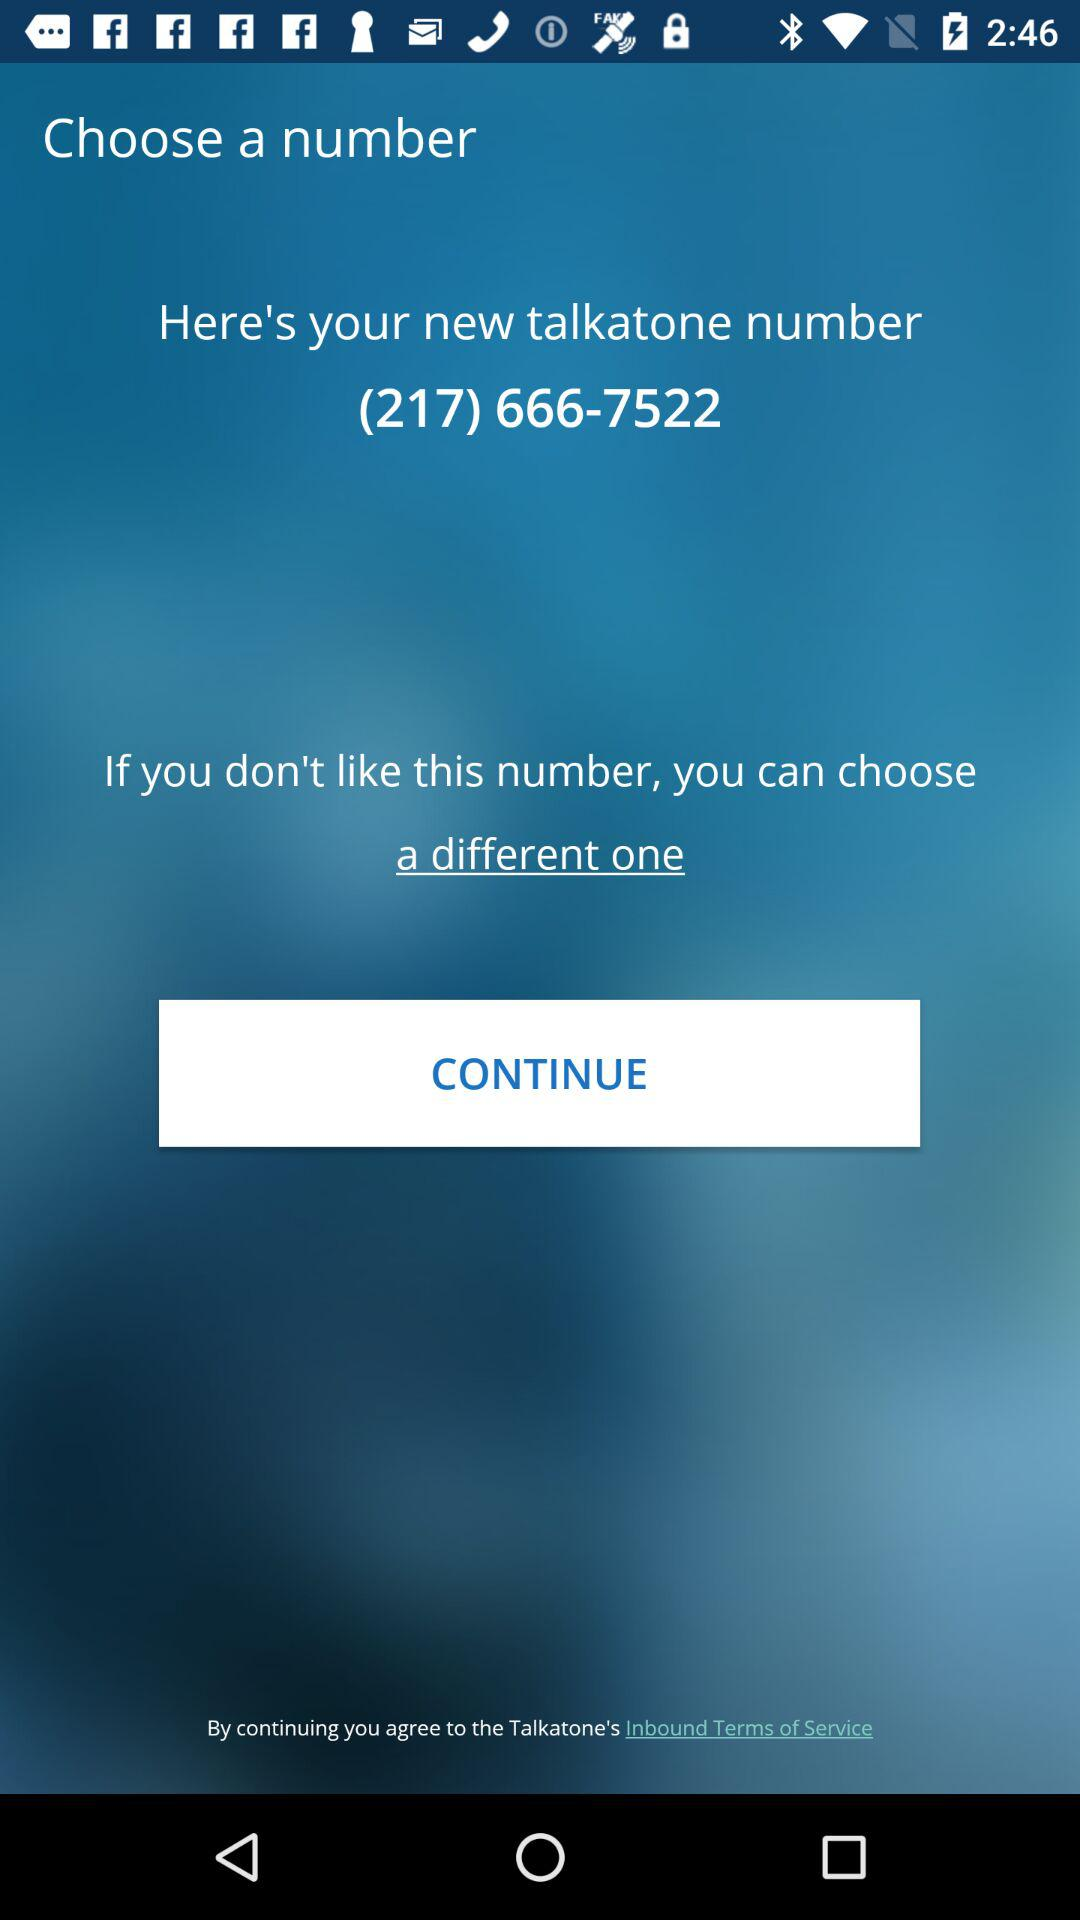What is the name of the application? The name of the application is "Talkatone". 